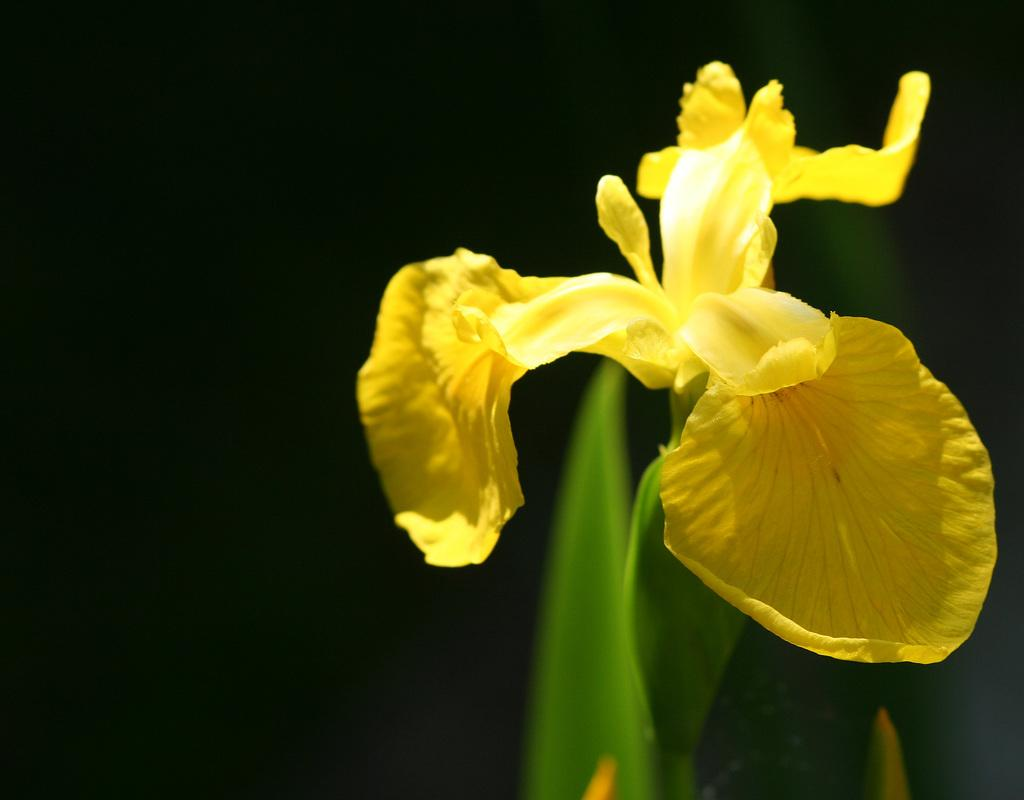What is the main subject of the image? The main subject of the image is a flower. Where is the flower located? The flower is present on a plant. How many locks are securing the tomatoes in the image? There are no tomatoes or locks present in the image; it features a flower on a plant. What type of wealth is depicted in the image? There is no depiction of wealth in the image; it features a flower on a plant. 